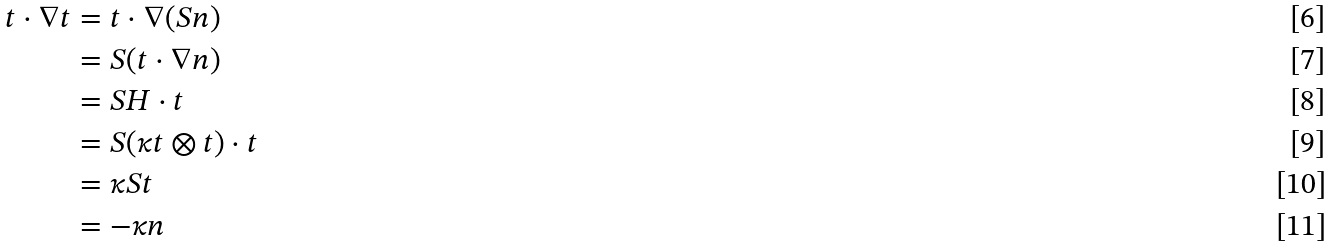<formula> <loc_0><loc_0><loc_500><loc_500>t \cdot \nabla t & = t \cdot \nabla ( S n ) \\ & = S ( t \cdot \nabla n ) \\ & = S H \cdot t \\ & = S ( \kappa t \otimes t ) \cdot t \\ & = \kappa S t \\ & = - \kappa n</formula> 